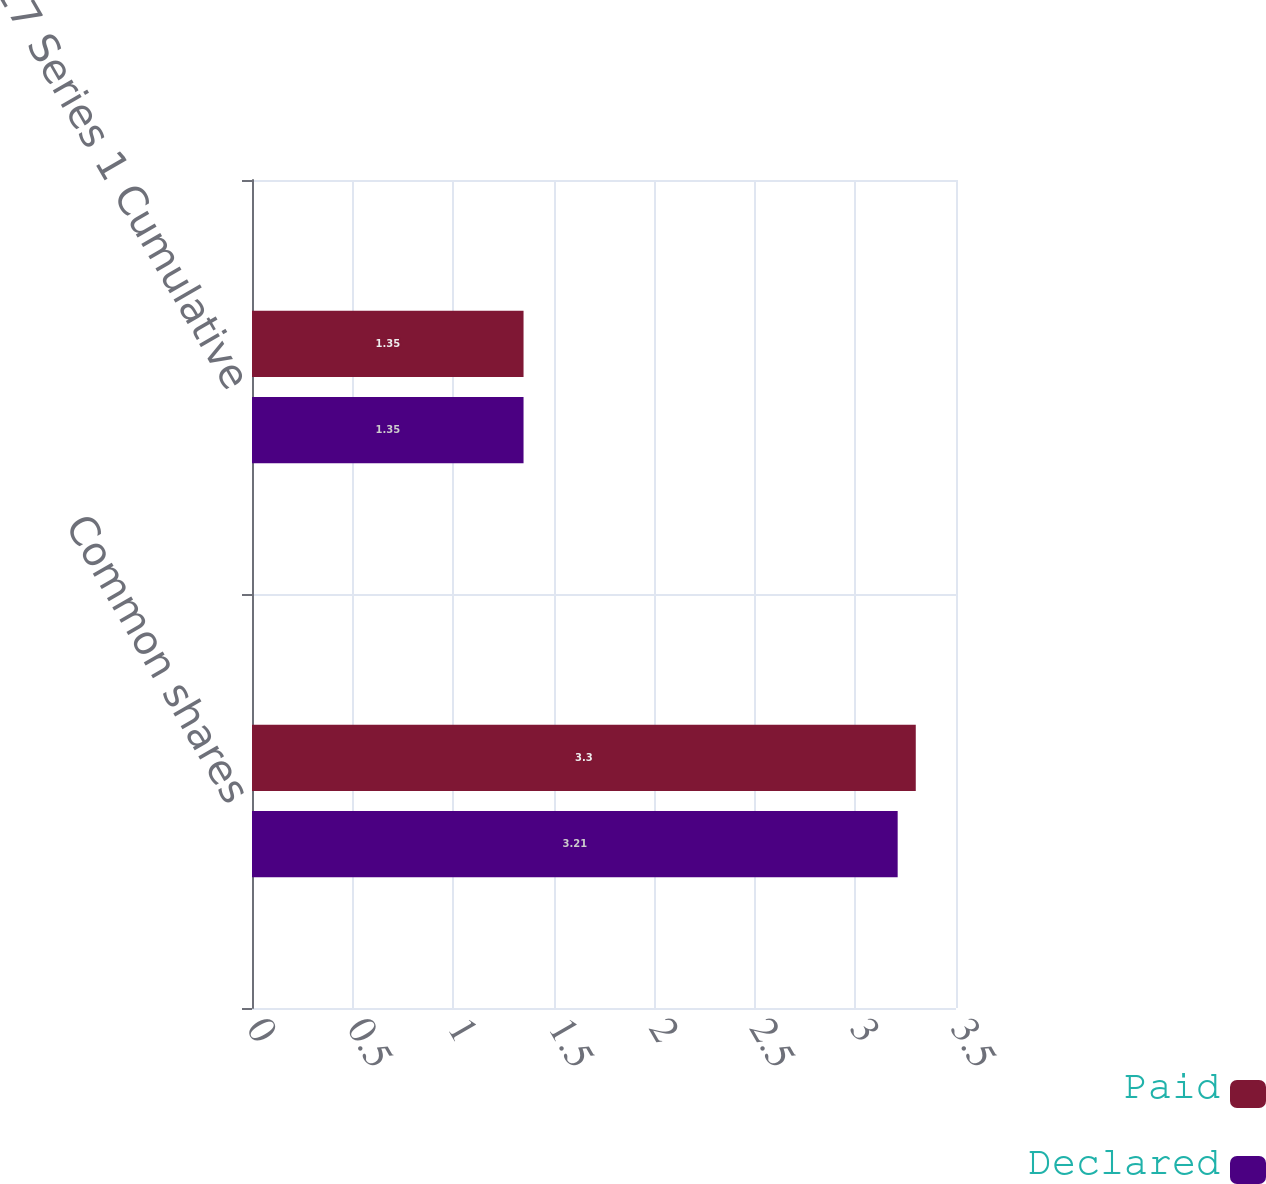Convert chart. <chart><loc_0><loc_0><loc_500><loc_500><stacked_bar_chart><ecel><fcel>Common shares<fcel>5417 Series 1 Cumulative<nl><fcel>Paid<fcel>3.3<fcel>1.35<nl><fcel>Declared<fcel>3.21<fcel>1.35<nl></chart> 